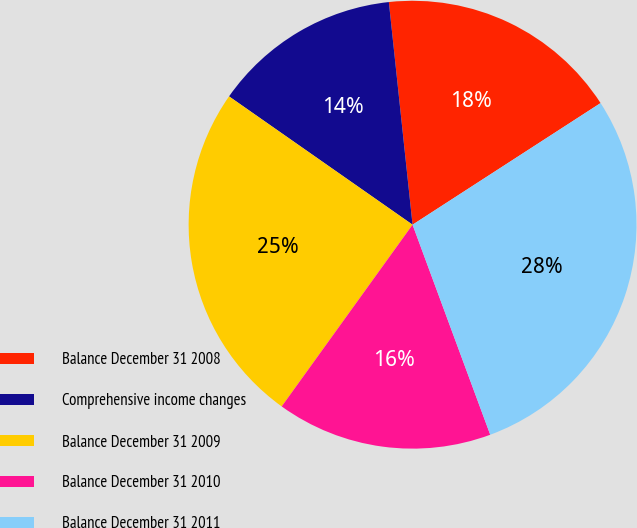Convert chart. <chart><loc_0><loc_0><loc_500><loc_500><pie_chart><fcel>Balance December 31 2008<fcel>Comprehensive income changes<fcel>Balance December 31 2009<fcel>Balance December 31 2010<fcel>Balance December 31 2011<nl><fcel>17.55%<fcel>13.6%<fcel>24.78%<fcel>15.57%<fcel>28.5%<nl></chart> 